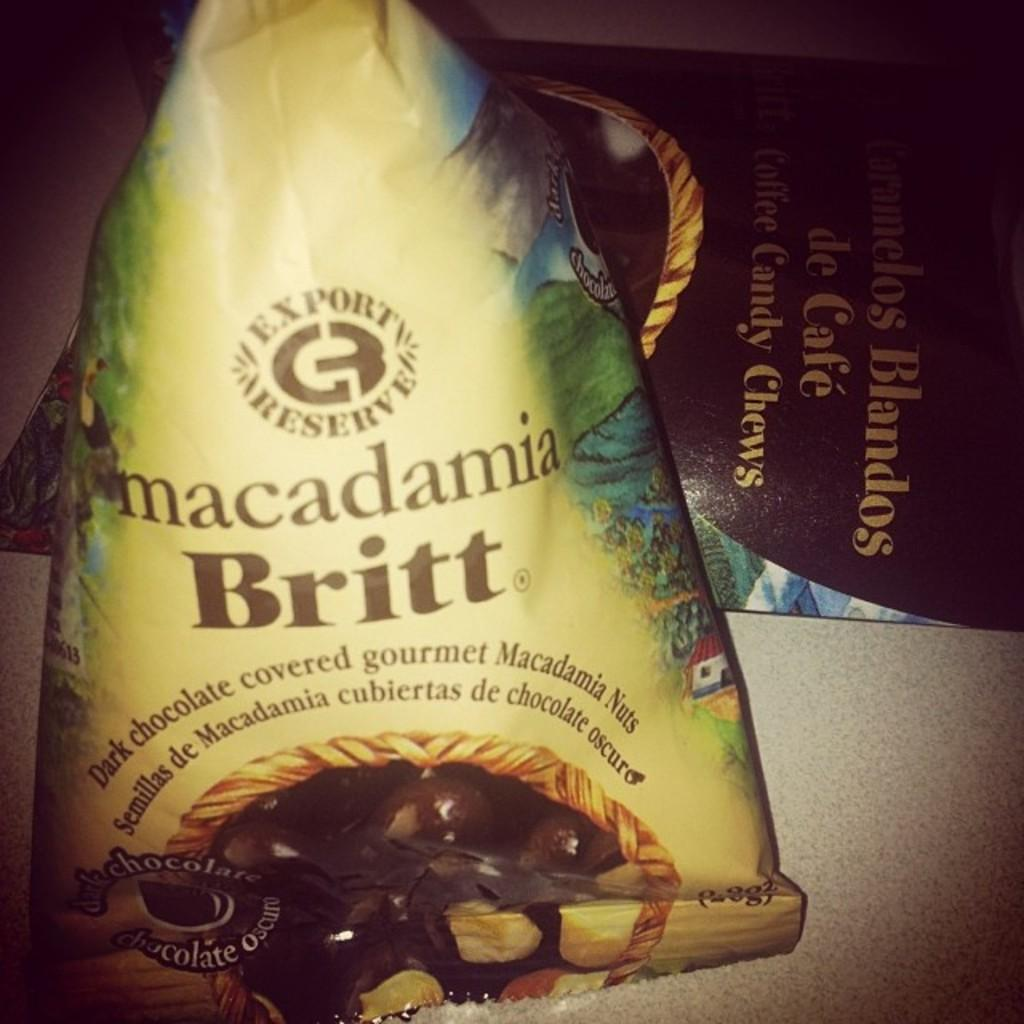Provide a one-sentence caption for the provided image. A package of dark chocolate macadamia nuts by Brit showing the chocolate covered nuts on the package. 